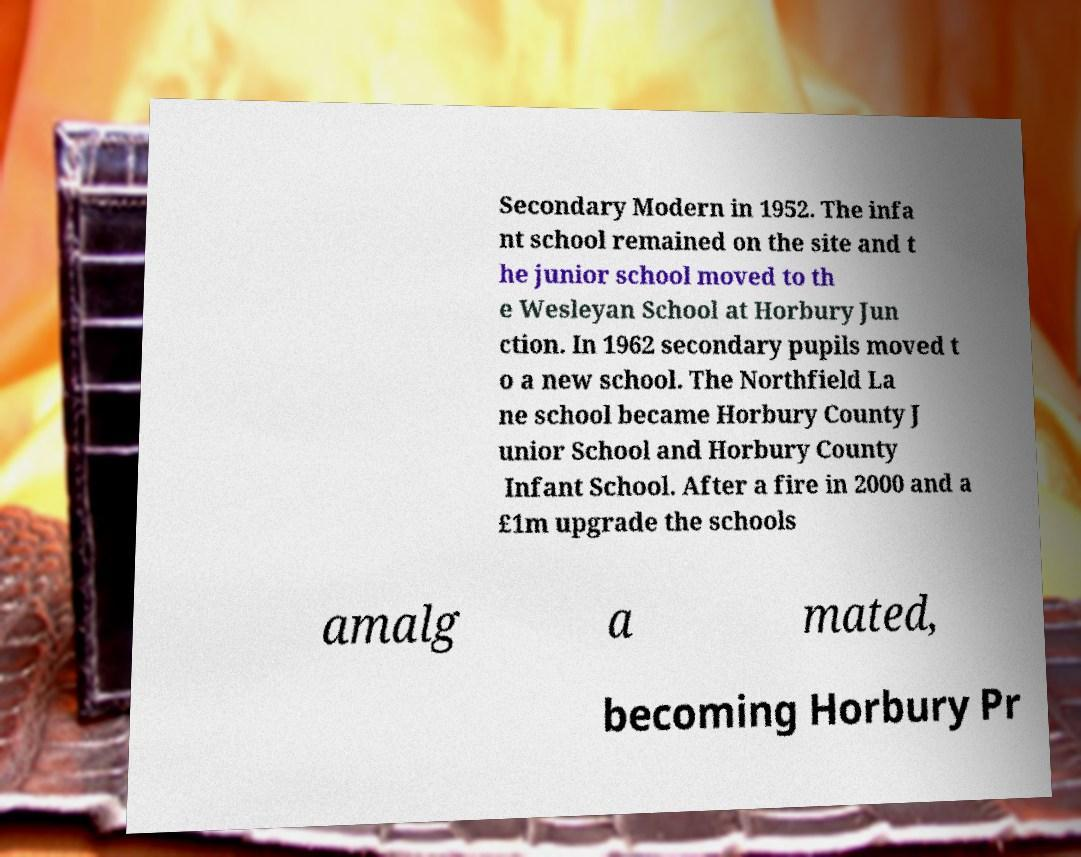Can you read and provide the text displayed in the image?This photo seems to have some interesting text. Can you extract and type it out for me? Secondary Modern in 1952. The infa nt school remained on the site and t he junior school moved to th e Wesleyan School at Horbury Jun ction. In 1962 secondary pupils moved t o a new school. The Northfield La ne school became Horbury County J unior School and Horbury County Infant School. After a fire in 2000 and a £1m upgrade the schools amalg a mated, becoming Horbury Pr 